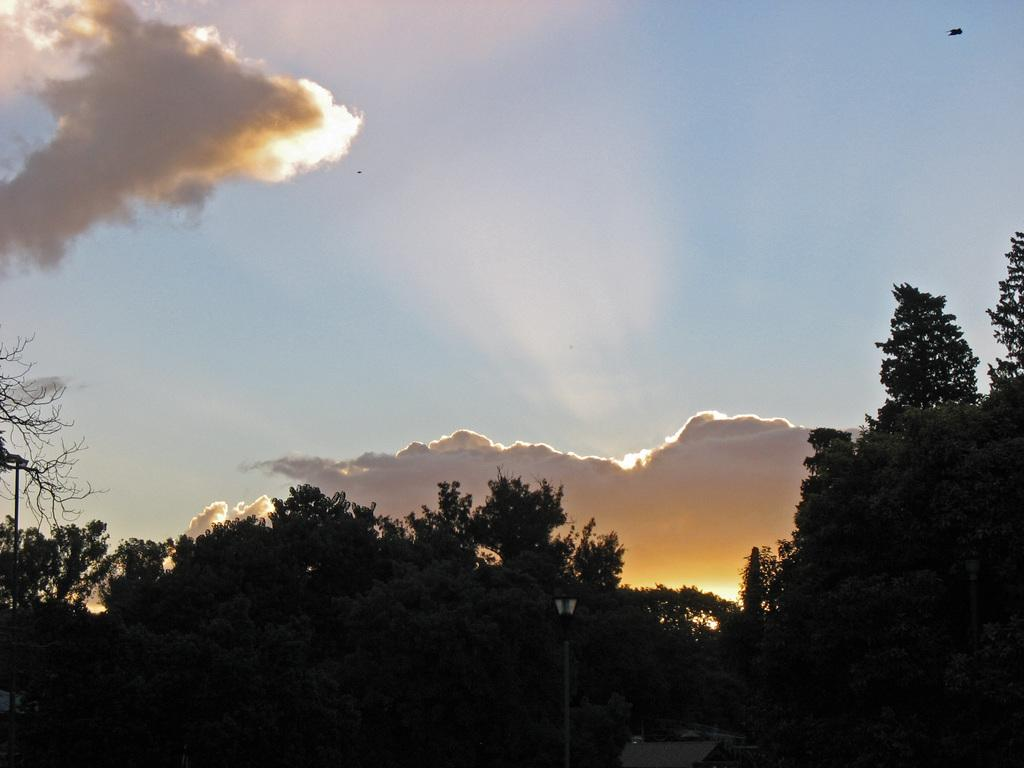What type of vegetation can be seen in the image? There are trees in the image, extending from left to right. What is the color of the sky in the image? The sky is blue in color. Can you describe the weather condition in the image? The sky is cloudy in the image. How many trains can be seen passing through the lettuce field in the image? There are no trains or lettuce fields present in the image. 